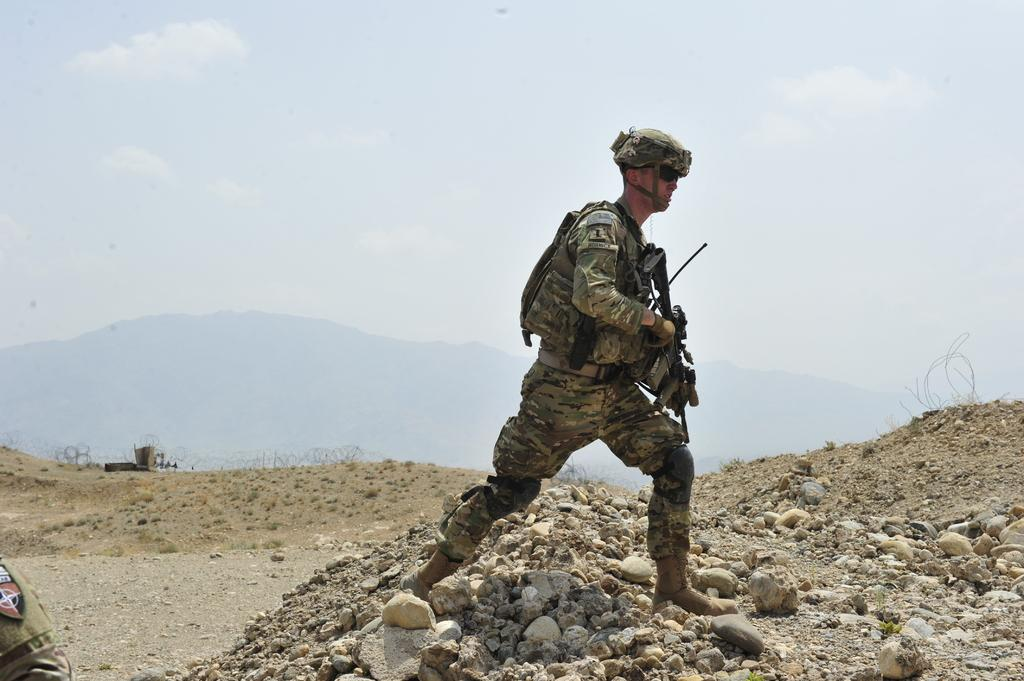What is the man in the image doing? The man is standing in the image and holding a gun. What can be seen on the ground in the image? There are stones visible in the image. What is in the background of the image? There is a mountain and the sky in the background of the image. What is the condition of the sky in the image? Clouds are present in the sky in the image. What type of substance is the worm crawling on in the image? There is no worm present in the image, so it is not possible to answer that question. 